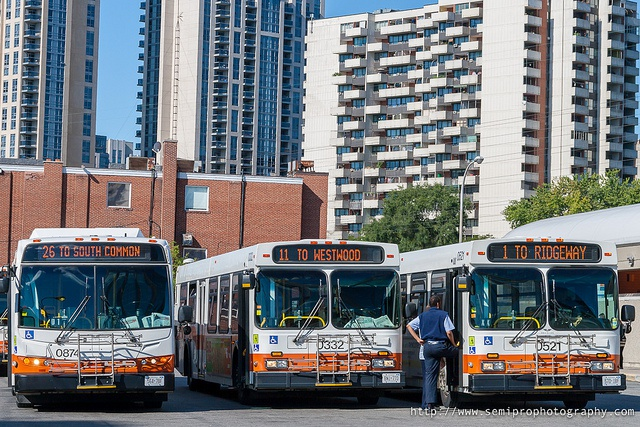Describe the objects in this image and their specific colors. I can see bus in gray, black, lightgray, and darkblue tones, bus in gray, black, lightgray, and darkblue tones, bus in gray, black, lightgray, navy, and blue tones, and people in gray, black, navy, and darkblue tones in this image. 